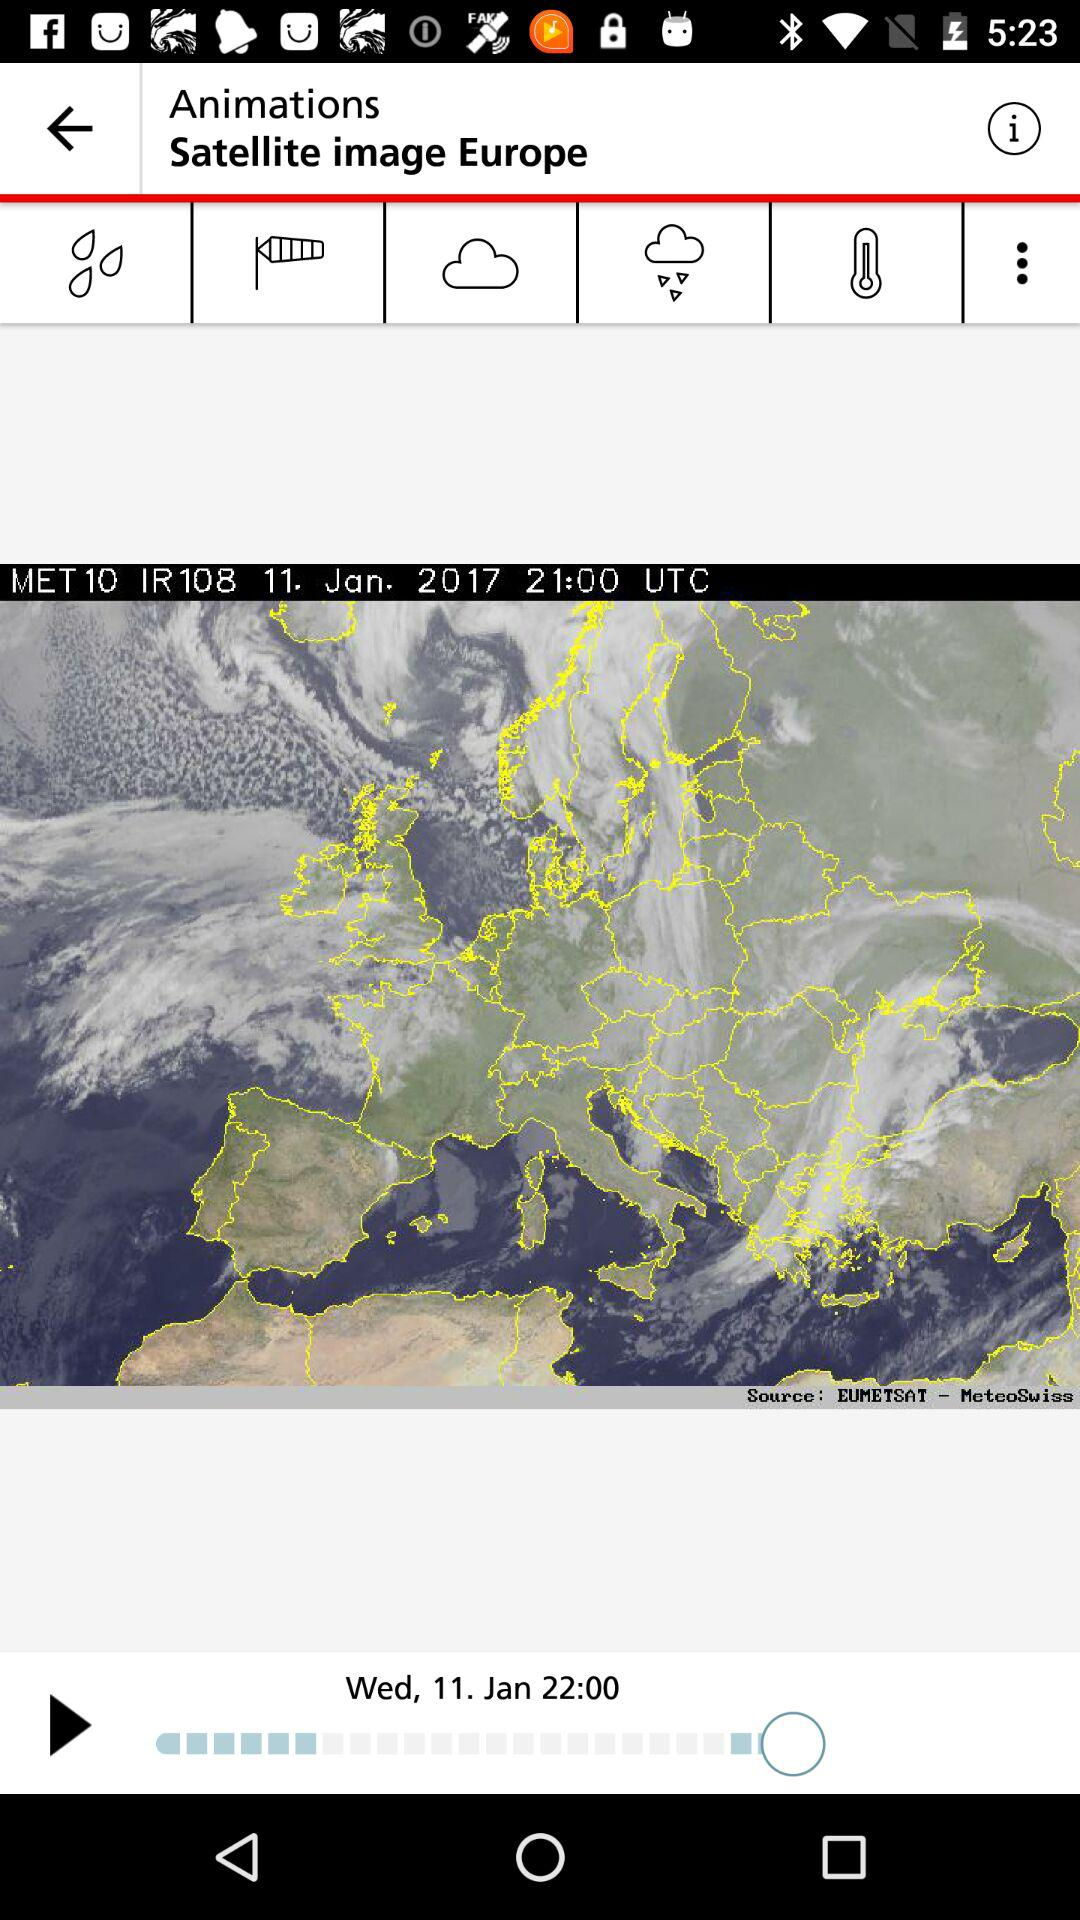What is the temperature?
When the provided information is insufficient, respond with <no answer>. <no answer> 